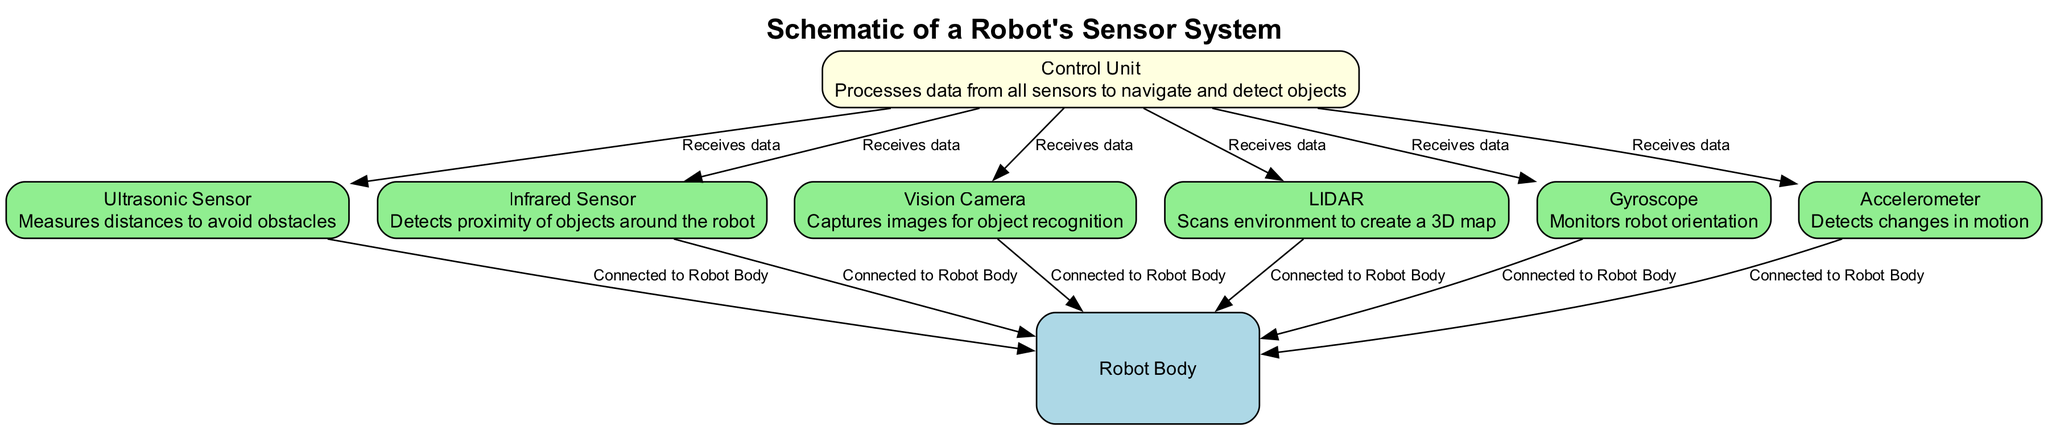What is the label of the central unit in the diagram? The central unit in the diagram is labeled "Robot Body". This is identified by looking for the node type marked as "main," which is the core component housing all sensors.
Answer: Robot Body How many types of sensors are shown in the diagram? The diagram depicts six types of sensors: Ultrasonic Sensor, Infrared Sensor, Vision Camera, LIDAR, Gyroscope, and Accelerometer. Counting each distinct sensor from the nodes tagged as "sensor" provides the total.
Answer: 6 Which sensor measures distances to avoid obstacles? The sensor specifically designed to measure distances to avoid obstacles is the "Ultrasonic Sensor". This is clarified by reviewing the description associated with that sensor node.
Answer: Ultrasonic Sensor What is the role of the Control Unit in the diagram? The Control Unit processes data from all sensors to enable navigation and object detection. This is deduced by examining the description provided for the Control Unit node which indicates its function involves processing data from connected sensors.
Answer: Processes data How many connections lead to the Control Unit? The Control Unit has five connections depicted in the diagram, as there are six sensors connected to it, including the Gyroscope and Accelerometer. Each connection reveals it receives data from all listed sensors.
Answer: 6 What type of sensor uses light detection for environment scanning? The sensor that uses light detection to scan the environment is the "LIDAR". This is established by looking at the node labeled LIDAR and its specific description mentioning "scans environment".
Answer: LIDAR Which sensor is responsible for monitoring robot orientation? The sensor designated for monitoring the robot's orientation is the "Gyroscope". This is confirmed by reviewing the description connected to the Gyroscope node in the diagram.
Answer: Gyroscope What flows from the Ultrasonic Sensor to the Control Unit? The flow from the Ultrasonic Sensor to the Control Unit consists of the data being received. This connection is indicated clearly with the labeled arrows showing the relationship between the nodes.
Answer: Data How many overall nodes are in the diagram? There are eight overall nodes in the diagram when counting all types: one main node, six sensor nodes, and one component node. The total can be seen by summing all nodes listed in the schematic.
Answer: 8 